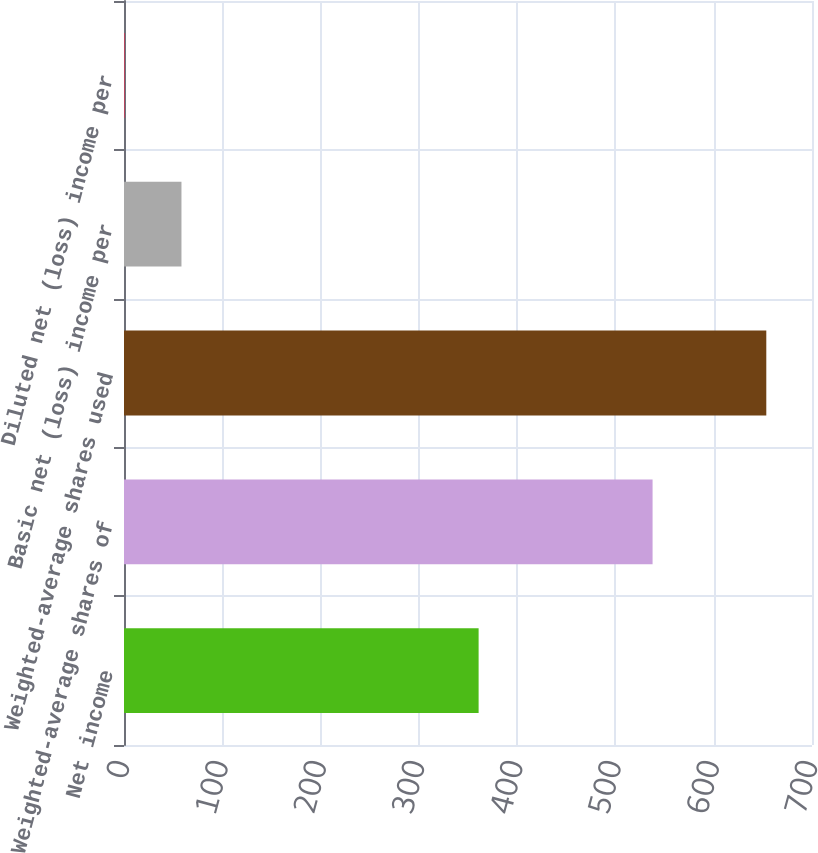<chart> <loc_0><loc_0><loc_500><loc_500><bar_chart><fcel>Net income<fcel>Weighted-average shares of<fcel>Weighted-average shares used<fcel>Basic net (loss) income per<fcel>Diluted net (loss) income per<nl><fcel>360.8<fcel>537.8<fcel>653.5<fcel>58.47<fcel>0.62<nl></chart> 